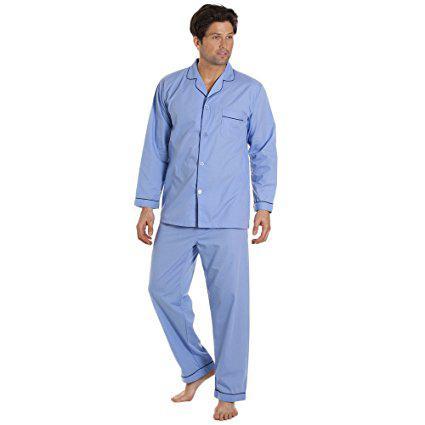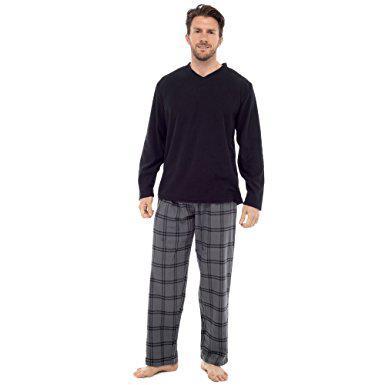The first image is the image on the left, the second image is the image on the right. Analyze the images presented: Is the assertion "All photos are full length shots of people modeling clothes." valid? Answer yes or no. Yes. The first image is the image on the left, the second image is the image on the right. Examine the images to the left and right. Is the description "The model on the right wears plaid bottoms and a dark, solid-colored top." accurate? Answer yes or no. Yes. 